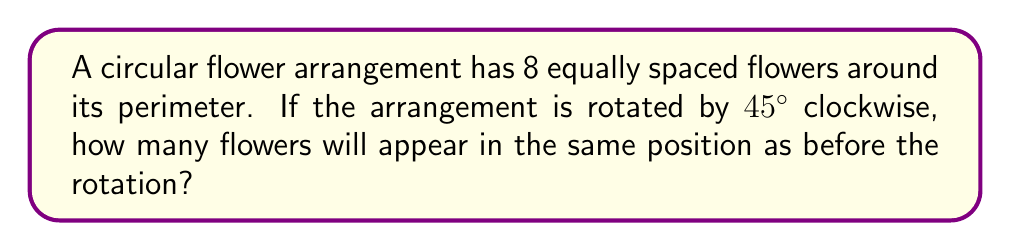Can you answer this question? Let's approach this step-by-step:

1) First, we need to understand the symmetry of the arrangement:
   - There are 8 flowers equally spaced around a circle.
   - This means each flower is separated by an angle of $\frac{360^\circ}{8} = 45^\circ$.

2) The rotation is $45^\circ$ clockwise, which is the same as the angle between each flower.

3) To determine how many flowers remain in the same position, we need to consider the rotational symmetry:
   - A rotation of $45^\circ$ is equivalent to moving each flower to the position of its neighbor.
   - In a full $360^\circ$ rotation, each flower would return to its original position.

4) The number of flowers that remain in the same position is determined by how many times $45^\circ$ goes into $360^\circ$:

   $$\frac{360^\circ}{45^\circ} = 8$$

5) This means that after 8 rotations of $45^\circ$, all flowers return to their original positions.

6) Therefore, every flower in this arrangement will be in a new position after a single $45^\circ$ rotation.

[asy]
unitsize(2cm);
for(int i=0; i<8; ++i) {
  dot(dir(45*i));
  label(dir(45*i), "$" + string(i+1) + "$", dir(45*i));
}
draw(circle((0,0),1));
[/asy]

In this diagram, after a $45^\circ$ clockwise rotation, flower 1 would move to the position of flower 8, flower 2 to the position of flower 1, and so on.
Answer: 0 flowers 